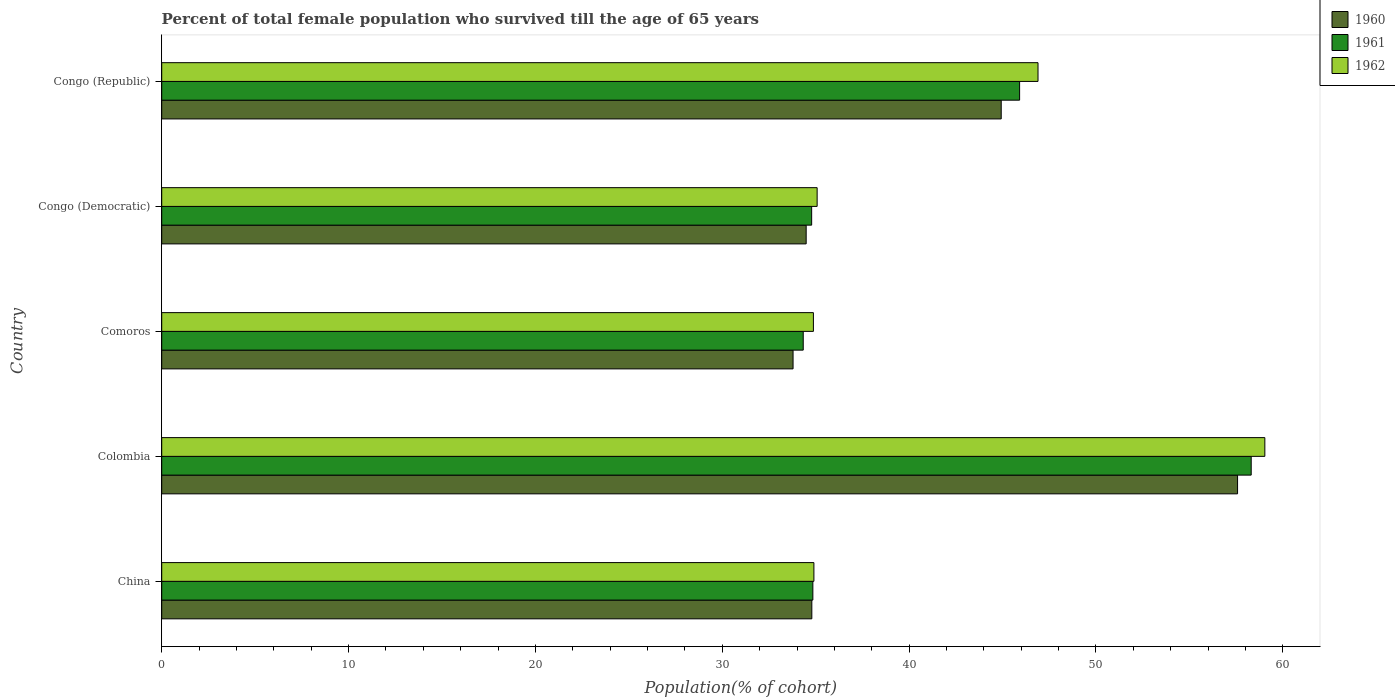Are the number of bars on each tick of the Y-axis equal?
Provide a short and direct response. Yes. What is the label of the 5th group of bars from the top?
Your answer should be very brief. China. In how many cases, is the number of bars for a given country not equal to the number of legend labels?
Keep it short and to the point. 0. What is the percentage of total female population who survived till the age of 65 years in 1962 in Congo (Democratic)?
Your answer should be very brief. 35.08. Across all countries, what is the maximum percentage of total female population who survived till the age of 65 years in 1961?
Provide a succinct answer. 58.31. Across all countries, what is the minimum percentage of total female population who survived till the age of 65 years in 1962?
Provide a succinct answer. 34.88. In which country was the percentage of total female population who survived till the age of 65 years in 1961 minimum?
Offer a very short reply. Comoros. What is the total percentage of total female population who survived till the age of 65 years in 1962 in the graph?
Your response must be concise. 210.79. What is the difference between the percentage of total female population who survived till the age of 65 years in 1962 in Colombia and that in Congo (Republic)?
Offer a very short reply. 12.14. What is the difference between the percentage of total female population who survived till the age of 65 years in 1960 in Comoros and the percentage of total female population who survived till the age of 65 years in 1962 in Congo (Republic)?
Ensure brevity in your answer.  -13.11. What is the average percentage of total female population who survived till the age of 65 years in 1960 per country?
Provide a short and direct response. 41.12. What is the difference between the percentage of total female population who survived till the age of 65 years in 1960 and percentage of total female population who survived till the age of 65 years in 1962 in Congo (Democratic)?
Offer a terse response. -0.59. In how many countries, is the percentage of total female population who survived till the age of 65 years in 1960 greater than 58 %?
Your answer should be very brief. 0. What is the ratio of the percentage of total female population who survived till the age of 65 years in 1962 in China to that in Colombia?
Provide a short and direct response. 0.59. Is the percentage of total female population who survived till the age of 65 years in 1962 in Comoros less than that in Congo (Democratic)?
Keep it short and to the point. Yes. What is the difference between the highest and the second highest percentage of total female population who survived till the age of 65 years in 1961?
Provide a short and direct response. 12.39. What is the difference between the highest and the lowest percentage of total female population who survived till the age of 65 years in 1961?
Provide a short and direct response. 23.97. Is the sum of the percentage of total female population who survived till the age of 65 years in 1961 in Colombia and Comoros greater than the maximum percentage of total female population who survived till the age of 65 years in 1960 across all countries?
Offer a terse response. Yes. What does the 1st bar from the bottom in Congo (Republic) represents?
Your response must be concise. 1960. Is it the case that in every country, the sum of the percentage of total female population who survived till the age of 65 years in 1962 and percentage of total female population who survived till the age of 65 years in 1960 is greater than the percentage of total female population who survived till the age of 65 years in 1961?
Provide a succinct answer. Yes. How many bars are there?
Provide a succinct answer. 15. Are all the bars in the graph horizontal?
Keep it short and to the point. Yes. How many countries are there in the graph?
Provide a succinct answer. 5. Does the graph contain any zero values?
Make the answer very short. No. Where does the legend appear in the graph?
Provide a succinct answer. Top right. How are the legend labels stacked?
Give a very brief answer. Vertical. What is the title of the graph?
Provide a succinct answer. Percent of total female population who survived till the age of 65 years. Does "1976" appear as one of the legend labels in the graph?
Keep it short and to the point. No. What is the label or title of the X-axis?
Offer a very short reply. Population(% of cohort). What is the label or title of the Y-axis?
Your answer should be compact. Country. What is the Population(% of cohort) of 1960 in China?
Provide a short and direct response. 34.79. What is the Population(% of cohort) of 1961 in China?
Ensure brevity in your answer.  34.85. What is the Population(% of cohort) of 1962 in China?
Offer a terse response. 34.9. What is the Population(% of cohort) in 1960 in Colombia?
Ensure brevity in your answer.  57.58. What is the Population(% of cohort) in 1961 in Colombia?
Offer a very short reply. 58.31. What is the Population(% of cohort) of 1962 in Colombia?
Your answer should be compact. 59.04. What is the Population(% of cohort) in 1960 in Comoros?
Your answer should be compact. 33.79. What is the Population(% of cohort) in 1961 in Comoros?
Your response must be concise. 34.33. What is the Population(% of cohort) of 1962 in Comoros?
Give a very brief answer. 34.88. What is the Population(% of cohort) in 1960 in Congo (Democratic)?
Offer a terse response. 34.49. What is the Population(% of cohort) of 1961 in Congo (Democratic)?
Your response must be concise. 34.78. What is the Population(% of cohort) of 1962 in Congo (Democratic)?
Make the answer very short. 35.08. What is the Population(% of cohort) in 1960 in Congo (Republic)?
Your answer should be very brief. 44.93. What is the Population(% of cohort) of 1961 in Congo (Republic)?
Provide a short and direct response. 45.91. What is the Population(% of cohort) of 1962 in Congo (Republic)?
Your answer should be very brief. 46.9. Across all countries, what is the maximum Population(% of cohort) of 1960?
Offer a terse response. 57.58. Across all countries, what is the maximum Population(% of cohort) of 1961?
Your answer should be compact. 58.31. Across all countries, what is the maximum Population(% of cohort) in 1962?
Offer a terse response. 59.04. Across all countries, what is the minimum Population(% of cohort) of 1960?
Your answer should be very brief. 33.79. Across all countries, what is the minimum Population(% of cohort) of 1961?
Your answer should be very brief. 34.33. Across all countries, what is the minimum Population(% of cohort) in 1962?
Make the answer very short. 34.88. What is the total Population(% of cohort) of 1960 in the graph?
Your answer should be compact. 205.58. What is the total Population(% of cohort) of 1961 in the graph?
Offer a very short reply. 208.19. What is the total Population(% of cohort) in 1962 in the graph?
Your answer should be compact. 210.79. What is the difference between the Population(% of cohort) of 1960 in China and that in Colombia?
Your response must be concise. -22.78. What is the difference between the Population(% of cohort) of 1961 in China and that in Colombia?
Give a very brief answer. -23.46. What is the difference between the Population(% of cohort) of 1962 in China and that in Colombia?
Your answer should be very brief. -24.13. What is the difference between the Population(% of cohort) of 1961 in China and that in Comoros?
Your answer should be compact. 0.52. What is the difference between the Population(% of cohort) in 1962 in China and that in Comoros?
Offer a terse response. 0.03. What is the difference between the Population(% of cohort) in 1960 in China and that in Congo (Democratic)?
Offer a terse response. 0.3. What is the difference between the Population(% of cohort) in 1961 in China and that in Congo (Democratic)?
Give a very brief answer. 0.06. What is the difference between the Population(% of cohort) in 1962 in China and that in Congo (Democratic)?
Give a very brief answer. -0.17. What is the difference between the Population(% of cohort) in 1960 in China and that in Congo (Republic)?
Ensure brevity in your answer.  -10.14. What is the difference between the Population(% of cohort) of 1961 in China and that in Congo (Republic)?
Provide a short and direct response. -11.06. What is the difference between the Population(% of cohort) of 1962 in China and that in Congo (Republic)?
Make the answer very short. -11.99. What is the difference between the Population(% of cohort) in 1960 in Colombia and that in Comoros?
Provide a succinct answer. 23.79. What is the difference between the Population(% of cohort) in 1961 in Colombia and that in Comoros?
Provide a short and direct response. 23.97. What is the difference between the Population(% of cohort) in 1962 in Colombia and that in Comoros?
Provide a succinct answer. 24.16. What is the difference between the Population(% of cohort) in 1960 in Colombia and that in Congo (Democratic)?
Your response must be concise. 23.09. What is the difference between the Population(% of cohort) of 1961 in Colombia and that in Congo (Democratic)?
Make the answer very short. 23.52. What is the difference between the Population(% of cohort) of 1962 in Colombia and that in Congo (Democratic)?
Your answer should be very brief. 23.96. What is the difference between the Population(% of cohort) of 1960 in Colombia and that in Congo (Republic)?
Offer a terse response. 12.65. What is the difference between the Population(% of cohort) of 1961 in Colombia and that in Congo (Republic)?
Offer a terse response. 12.39. What is the difference between the Population(% of cohort) in 1962 in Colombia and that in Congo (Republic)?
Make the answer very short. 12.14. What is the difference between the Population(% of cohort) of 1960 in Comoros and that in Congo (Democratic)?
Make the answer very short. -0.7. What is the difference between the Population(% of cohort) of 1961 in Comoros and that in Congo (Democratic)?
Offer a very short reply. -0.45. What is the difference between the Population(% of cohort) of 1962 in Comoros and that in Congo (Democratic)?
Give a very brief answer. -0.2. What is the difference between the Population(% of cohort) of 1960 in Comoros and that in Congo (Republic)?
Provide a succinct answer. -11.14. What is the difference between the Population(% of cohort) in 1961 in Comoros and that in Congo (Republic)?
Offer a very short reply. -11.58. What is the difference between the Population(% of cohort) of 1962 in Comoros and that in Congo (Republic)?
Offer a terse response. -12.02. What is the difference between the Population(% of cohort) in 1960 in Congo (Democratic) and that in Congo (Republic)?
Give a very brief answer. -10.44. What is the difference between the Population(% of cohort) of 1961 in Congo (Democratic) and that in Congo (Republic)?
Make the answer very short. -11.13. What is the difference between the Population(% of cohort) in 1962 in Congo (Democratic) and that in Congo (Republic)?
Make the answer very short. -11.82. What is the difference between the Population(% of cohort) of 1960 in China and the Population(% of cohort) of 1961 in Colombia?
Make the answer very short. -23.51. What is the difference between the Population(% of cohort) of 1960 in China and the Population(% of cohort) of 1962 in Colombia?
Offer a very short reply. -24.24. What is the difference between the Population(% of cohort) of 1961 in China and the Population(% of cohort) of 1962 in Colombia?
Make the answer very short. -24.19. What is the difference between the Population(% of cohort) of 1960 in China and the Population(% of cohort) of 1961 in Comoros?
Offer a very short reply. 0.46. What is the difference between the Population(% of cohort) in 1960 in China and the Population(% of cohort) in 1962 in Comoros?
Keep it short and to the point. -0.08. What is the difference between the Population(% of cohort) in 1961 in China and the Population(% of cohort) in 1962 in Comoros?
Offer a very short reply. -0.03. What is the difference between the Population(% of cohort) in 1960 in China and the Population(% of cohort) in 1961 in Congo (Democratic)?
Provide a short and direct response. 0.01. What is the difference between the Population(% of cohort) in 1960 in China and the Population(% of cohort) in 1962 in Congo (Democratic)?
Your response must be concise. -0.28. What is the difference between the Population(% of cohort) of 1961 in China and the Population(% of cohort) of 1962 in Congo (Democratic)?
Offer a very short reply. -0.23. What is the difference between the Population(% of cohort) of 1960 in China and the Population(% of cohort) of 1961 in Congo (Republic)?
Your answer should be compact. -11.12. What is the difference between the Population(% of cohort) of 1960 in China and the Population(% of cohort) of 1962 in Congo (Republic)?
Keep it short and to the point. -12.11. What is the difference between the Population(% of cohort) in 1961 in China and the Population(% of cohort) in 1962 in Congo (Republic)?
Offer a terse response. -12.05. What is the difference between the Population(% of cohort) in 1960 in Colombia and the Population(% of cohort) in 1961 in Comoros?
Offer a very short reply. 23.24. What is the difference between the Population(% of cohort) of 1960 in Colombia and the Population(% of cohort) of 1962 in Comoros?
Your response must be concise. 22.7. What is the difference between the Population(% of cohort) in 1961 in Colombia and the Population(% of cohort) in 1962 in Comoros?
Make the answer very short. 23.43. What is the difference between the Population(% of cohort) of 1960 in Colombia and the Population(% of cohort) of 1961 in Congo (Democratic)?
Provide a succinct answer. 22.79. What is the difference between the Population(% of cohort) in 1960 in Colombia and the Population(% of cohort) in 1962 in Congo (Democratic)?
Give a very brief answer. 22.5. What is the difference between the Population(% of cohort) in 1961 in Colombia and the Population(% of cohort) in 1962 in Congo (Democratic)?
Your response must be concise. 23.23. What is the difference between the Population(% of cohort) of 1960 in Colombia and the Population(% of cohort) of 1961 in Congo (Republic)?
Offer a terse response. 11.66. What is the difference between the Population(% of cohort) of 1960 in Colombia and the Population(% of cohort) of 1962 in Congo (Republic)?
Ensure brevity in your answer.  10.68. What is the difference between the Population(% of cohort) in 1961 in Colombia and the Population(% of cohort) in 1962 in Congo (Republic)?
Give a very brief answer. 11.41. What is the difference between the Population(% of cohort) of 1960 in Comoros and the Population(% of cohort) of 1961 in Congo (Democratic)?
Keep it short and to the point. -1. What is the difference between the Population(% of cohort) of 1960 in Comoros and the Population(% of cohort) of 1962 in Congo (Democratic)?
Ensure brevity in your answer.  -1.29. What is the difference between the Population(% of cohort) in 1961 in Comoros and the Population(% of cohort) in 1962 in Congo (Democratic)?
Provide a succinct answer. -0.74. What is the difference between the Population(% of cohort) in 1960 in Comoros and the Population(% of cohort) in 1961 in Congo (Republic)?
Your answer should be compact. -12.12. What is the difference between the Population(% of cohort) in 1960 in Comoros and the Population(% of cohort) in 1962 in Congo (Republic)?
Keep it short and to the point. -13.11. What is the difference between the Population(% of cohort) of 1961 in Comoros and the Population(% of cohort) of 1962 in Congo (Republic)?
Provide a short and direct response. -12.56. What is the difference between the Population(% of cohort) of 1960 in Congo (Democratic) and the Population(% of cohort) of 1961 in Congo (Republic)?
Ensure brevity in your answer.  -11.42. What is the difference between the Population(% of cohort) in 1960 in Congo (Democratic) and the Population(% of cohort) in 1962 in Congo (Republic)?
Provide a succinct answer. -12.41. What is the difference between the Population(% of cohort) of 1961 in Congo (Democratic) and the Population(% of cohort) of 1962 in Congo (Republic)?
Give a very brief answer. -12.11. What is the average Population(% of cohort) in 1960 per country?
Provide a short and direct response. 41.12. What is the average Population(% of cohort) in 1961 per country?
Your answer should be very brief. 41.64. What is the average Population(% of cohort) in 1962 per country?
Your response must be concise. 42.16. What is the difference between the Population(% of cohort) of 1960 and Population(% of cohort) of 1961 in China?
Offer a very short reply. -0.06. What is the difference between the Population(% of cohort) of 1960 and Population(% of cohort) of 1962 in China?
Your answer should be very brief. -0.11. What is the difference between the Population(% of cohort) of 1961 and Population(% of cohort) of 1962 in China?
Your answer should be very brief. -0.06. What is the difference between the Population(% of cohort) in 1960 and Population(% of cohort) in 1961 in Colombia?
Ensure brevity in your answer.  -0.73. What is the difference between the Population(% of cohort) of 1960 and Population(% of cohort) of 1962 in Colombia?
Offer a terse response. -1.46. What is the difference between the Population(% of cohort) in 1961 and Population(% of cohort) in 1962 in Colombia?
Your response must be concise. -0.73. What is the difference between the Population(% of cohort) of 1960 and Population(% of cohort) of 1961 in Comoros?
Offer a very short reply. -0.54. What is the difference between the Population(% of cohort) of 1960 and Population(% of cohort) of 1962 in Comoros?
Keep it short and to the point. -1.09. What is the difference between the Population(% of cohort) of 1961 and Population(% of cohort) of 1962 in Comoros?
Offer a terse response. -0.54. What is the difference between the Population(% of cohort) of 1960 and Population(% of cohort) of 1961 in Congo (Democratic)?
Offer a very short reply. -0.29. What is the difference between the Population(% of cohort) in 1960 and Population(% of cohort) in 1962 in Congo (Democratic)?
Your answer should be very brief. -0.59. What is the difference between the Population(% of cohort) in 1961 and Population(% of cohort) in 1962 in Congo (Democratic)?
Your answer should be compact. -0.29. What is the difference between the Population(% of cohort) of 1960 and Population(% of cohort) of 1961 in Congo (Republic)?
Keep it short and to the point. -0.98. What is the difference between the Population(% of cohort) in 1960 and Population(% of cohort) in 1962 in Congo (Republic)?
Ensure brevity in your answer.  -1.97. What is the difference between the Population(% of cohort) in 1961 and Population(% of cohort) in 1962 in Congo (Republic)?
Make the answer very short. -0.98. What is the ratio of the Population(% of cohort) in 1960 in China to that in Colombia?
Keep it short and to the point. 0.6. What is the ratio of the Population(% of cohort) in 1961 in China to that in Colombia?
Ensure brevity in your answer.  0.6. What is the ratio of the Population(% of cohort) in 1962 in China to that in Colombia?
Offer a terse response. 0.59. What is the ratio of the Population(% of cohort) of 1960 in China to that in Comoros?
Your answer should be very brief. 1.03. What is the ratio of the Population(% of cohort) of 1961 in China to that in Comoros?
Your answer should be very brief. 1.01. What is the ratio of the Population(% of cohort) of 1960 in China to that in Congo (Democratic)?
Make the answer very short. 1.01. What is the ratio of the Population(% of cohort) in 1960 in China to that in Congo (Republic)?
Ensure brevity in your answer.  0.77. What is the ratio of the Population(% of cohort) of 1961 in China to that in Congo (Republic)?
Your answer should be very brief. 0.76. What is the ratio of the Population(% of cohort) in 1962 in China to that in Congo (Republic)?
Your answer should be very brief. 0.74. What is the ratio of the Population(% of cohort) of 1960 in Colombia to that in Comoros?
Ensure brevity in your answer.  1.7. What is the ratio of the Population(% of cohort) of 1961 in Colombia to that in Comoros?
Your answer should be very brief. 1.7. What is the ratio of the Population(% of cohort) in 1962 in Colombia to that in Comoros?
Your answer should be very brief. 1.69. What is the ratio of the Population(% of cohort) of 1960 in Colombia to that in Congo (Democratic)?
Your answer should be very brief. 1.67. What is the ratio of the Population(% of cohort) in 1961 in Colombia to that in Congo (Democratic)?
Give a very brief answer. 1.68. What is the ratio of the Population(% of cohort) in 1962 in Colombia to that in Congo (Democratic)?
Make the answer very short. 1.68. What is the ratio of the Population(% of cohort) of 1960 in Colombia to that in Congo (Republic)?
Your response must be concise. 1.28. What is the ratio of the Population(% of cohort) in 1961 in Colombia to that in Congo (Republic)?
Give a very brief answer. 1.27. What is the ratio of the Population(% of cohort) in 1962 in Colombia to that in Congo (Republic)?
Your answer should be very brief. 1.26. What is the ratio of the Population(% of cohort) in 1960 in Comoros to that in Congo (Democratic)?
Offer a very short reply. 0.98. What is the ratio of the Population(% of cohort) in 1960 in Comoros to that in Congo (Republic)?
Keep it short and to the point. 0.75. What is the ratio of the Population(% of cohort) of 1961 in Comoros to that in Congo (Republic)?
Give a very brief answer. 0.75. What is the ratio of the Population(% of cohort) in 1962 in Comoros to that in Congo (Republic)?
Ensure brevity in your answer.  0.74. What is the ratio of the Population(% of cohort) in 1960 in Congo (Democratic) to that in Congo (Republic)?
Offer a terse response. 0.77. What is the ratio of the Population(% of cohort) in 1961 in Congo (Democratic) to that in Congo (Republic)?
Make the answer very short. 0.76. What is the ratio of the Population(% of cohort) of 1962 in Congo (Democratic) to that in Congo (Republic)?
Keep it short and to the point. 0.75. What is the difference between the highest and the second highest Population(% of cohort) in 1960?
Your answer should be compact. 12.65. What is the difference between the highest and the second highest Population(% of cohort) in 1961?
Provide a succinct answer. 12.39. What is the difference between the highest and the second highest Population(% of cohort) of 1962?
Make the answer very short. 12.14. What is the difference between the highest and the lowest Population(% of cohort) in 1960?
Offer a terse response. 23.79. What is the difference between the highest and the lowest Population(% of cohort) of 1961?
Provide a short and direct response. 23.97. What is the difference between the highest and the lowest Population(% of cohort) in 1962?
Provide a succinct answer. 24.16. 